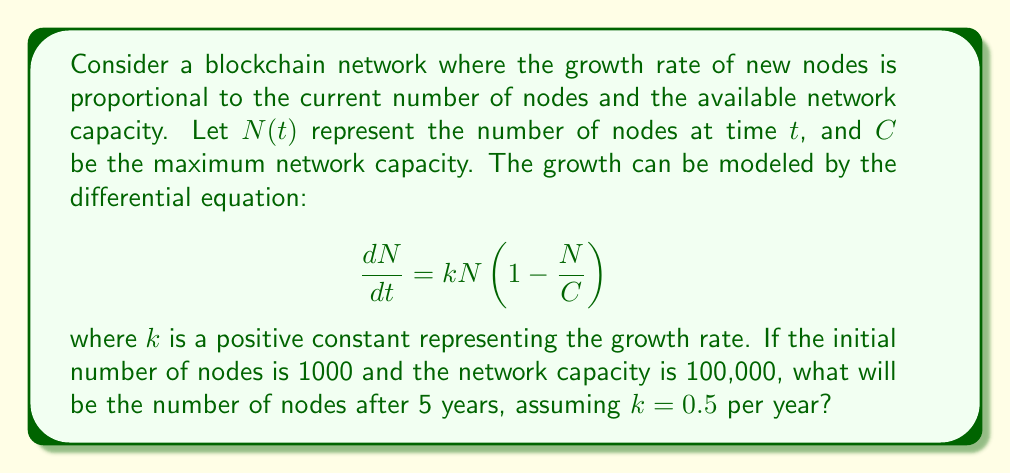Provide a solution to this math problem. To solve this problem, we need to follow these steps:

1) The given differential equation is a logistic growth model:

   $$\frac{dN}{dt} = kN(1 - \frac{N}{C})$$

2) The solution to this equation is:

   $$N(t) = \frac{C}{1 + (\frac{C}{N_0} - 1)e^{-kt}}$$

   where $N_0$ is the initial number of nodes.

3) We're given:
   - $N_0 = 1000$ (initial nodes)
   - $C = 100,000$ (network capacity)
   - $k = 0.5$ per year
   - $t = 5$ years

4) Let's substitute these values into the solution:

   $$N(5) = \frac{100000}{1 + (\frac{100000}{1000} - 1)e^{-0.5 \cdot 5}}$$

5) Simplify:
   $$N(5) = \frac{100000}{1 + 99e^{-2.5}}$$

6) Calculate:
   $$N(5) \approx 7,586.31$$

7) Since we're dealing with nodes, we round down to the nearest whole number.
Answer: 7,586 nodes 